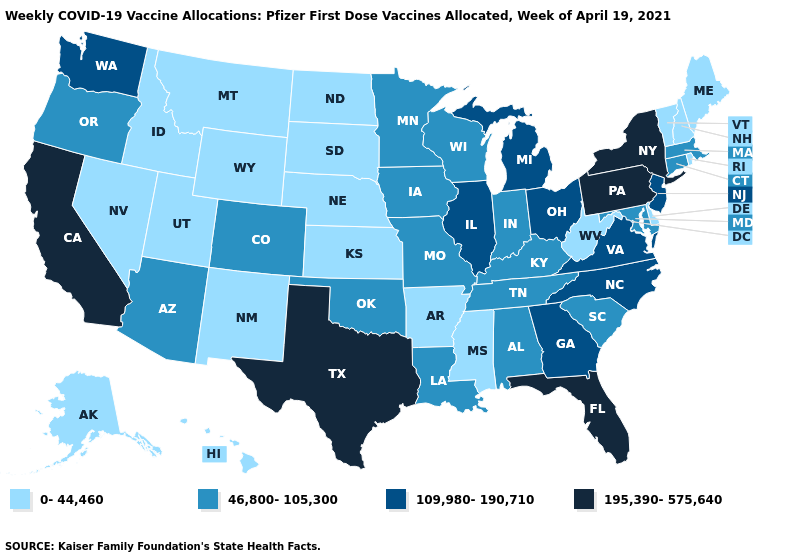What is the lowest value in the USA?
Write a very short answer. 0-44,460. Which states have the highest value in the USA?
Write a very short answer. California, Florida, New York, Pennsylvania, Texas. What is the value of Georgia?
Write a very short answer. 109,980-190,710. Name the states that have a value in the range 46,800-105,300?
Give a very brief answer. Alabama, Arizona, Colorado, Connecticut, Indiana, Iowa, Kentucky, Louisiana, Maryland, Massachusetts, Minnesota, Missouri, Oklahoma, Oregon, South Carolina, Tennessee, Wisconsin. What is the value of Mississippi?
Write a very short answer. 0-44,460. What is the highest value in the MidWest ?
Write a very short answer. 109,980-190,710. Does Colorado have the lowest value in the USA?
Keep it brief. No. What is the highest value in the USA?
Keep it brief. 195,390-575,640. Which states have the lowest value in the USA?
Quick response, please. Alaska, Arkansas, Delaware, Hawaii, Idaho, Kansas, Maine, Mississippi, Montana, Nebraska, Nevada, New Hampshire, New Mexico, North Dakota, Rhode Island, South Dakota, Utah, Vermont, West Virginia, Wyoming. What is the value of Missouri?
Answer briefly. 46,800-105,300. Among the states that border Texas , does Oklahoma have the highest value?
Keep it brief. Yes. Which states have the highest value in the USA?
Be succinct. California, Florida, New York, Pennsylvania, Texas. Which states have the lowest value in the USA?
Write a very short answer. Alaska, Arkansas, Delaware, Hawaii, Idaho, Kansas, Maine, Mississippi, Montana, Nebraska, Nevada, New Hampshire, New Mexico, North Dakota, Rhode Island, South Dakota, Utah, Vermont, West Virginia, Wyoming. Name the states that have a value in the range 0-44,460?
Quick response, please. Alaska, Arkansas, Delaware, Hawaii, Idaho, Kansas, Maine, Mississippi, Montana, Nebraska, Nevada, New Hampshire, New Mexico, North Dakota, Rhode Island, South Dakota, Utah, Vermont, West Virginia, Wyoming. Among the states that border Wisconsin , does Minnesota have the highest value?
Quick response, please. No. 